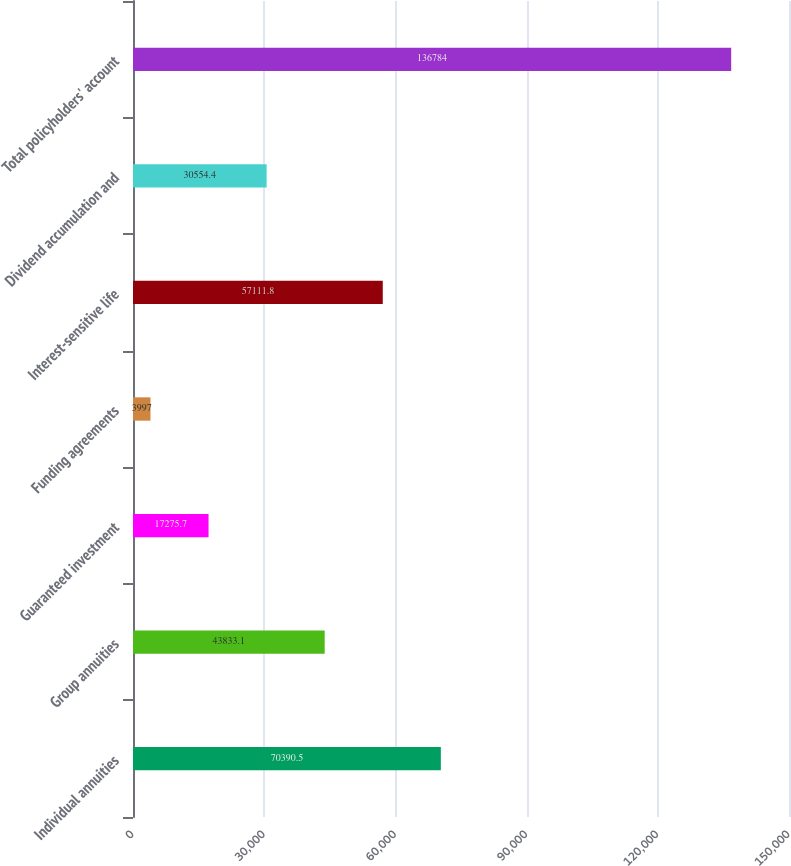Convert chart to OTSL. <chart><loc_0><loc_0><loc_500><loc_500><bar_chart><fcel>Individual annuities<fcel>Group annuities<fcel>Guaranteed investment<fcel>Funding agreements<fcel>Interest-sensitive life<fcel>Dividend accumulation and<fcel>Total policyholders' account<nl><fcel>70390.5<fcel>43833.1<fcel>17275.7<fcel>3997<fcel>57111.8<fcel>30554.4<fcel>136784<nl></chart> 